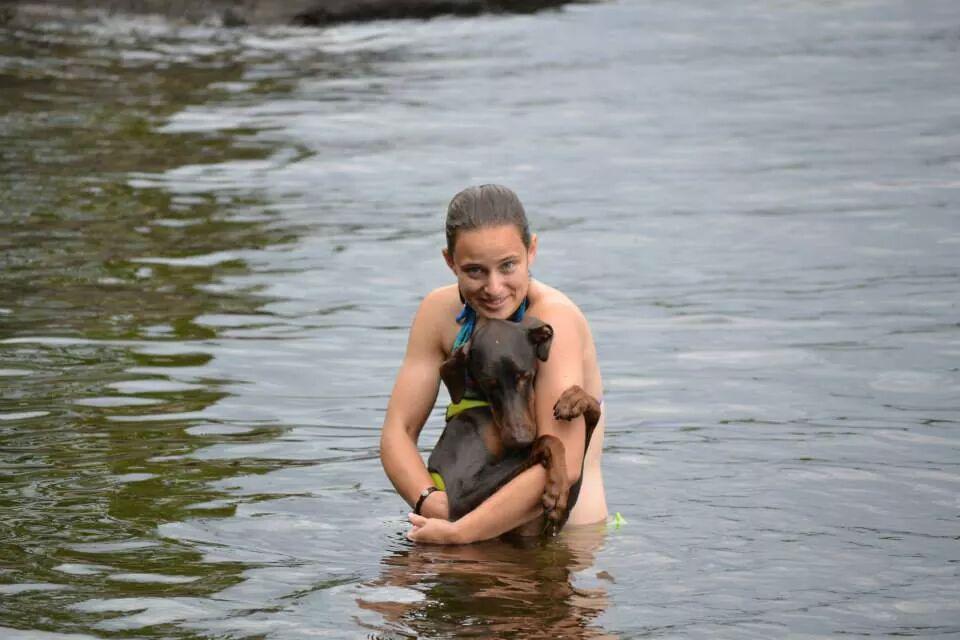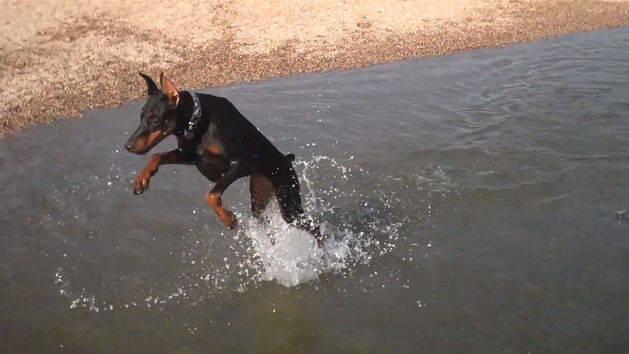The first image is the image on the left, the second image is the image on the right. Assess this claim about the two images: "There are three animals in the water.". Correct or not? Answer yes or no. Yes. The first image is the image on the left, the second image is the image on the right. For the images shown, is this caption "The dog in each image is alone in the water." true? Answer yes or no. No. 